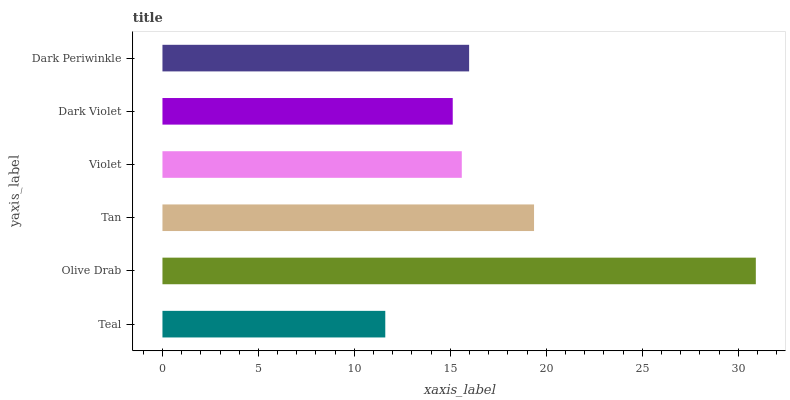Is Teal the minimum?
Answer yes or no. Yes. Is Olive Drab the maximum?
Answer yes or no. Yes. Is Tan the minimum?
Answer yes or no. No. Is Tan the maximum?
Answer yes or no. No. Is Olive Drab greater than Tan?
Answer yes or no. Yes. Is Tan less than Olive Drab?
Answer yes or no. Yes. Is Tan greater than Olive Drab?
Answer yes or no. No. Is Olive Drab less than Tan?
Answer yes or no. No. Is Dark Periwinkle the high median?
Answer yes or no. Yes. Is Violet the low median?
Answer yes or no. Yes. Is Dark Violet the high median?
Answer yes or no. No. Is Dark Violet the low median?
Answer yes or no. No. 